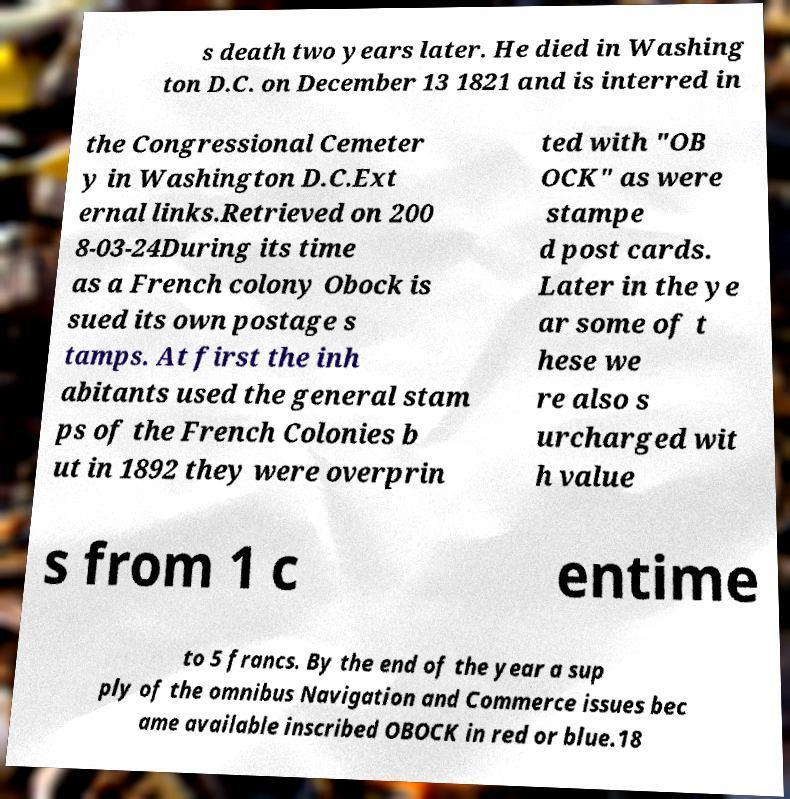For documentation purposes, I need the text within this image transcribed. Could you provide that? s death two years later. He died in Washing ton D.C. on December 13 1821 and is interred in the Congressional Cemeter y in Washington D.C.Ext ernal links.Retrieved on 200 8-03-24During its time as a French colony Obock is sued its own postage s tamps. At first the inh abitants used the general stam ps of the French Colonies b ut in 1892 they were overprin ted with "OB OCK" as were stampe d post cards. Later in the ye ar some of t hese we re also s urcharged wit h value s from 1 c entime to 5 francs. By the end of the year a sup ply of the omnibus Navigation and Commerce issues bec ame available inscribed OBOCK in red or blue.18 